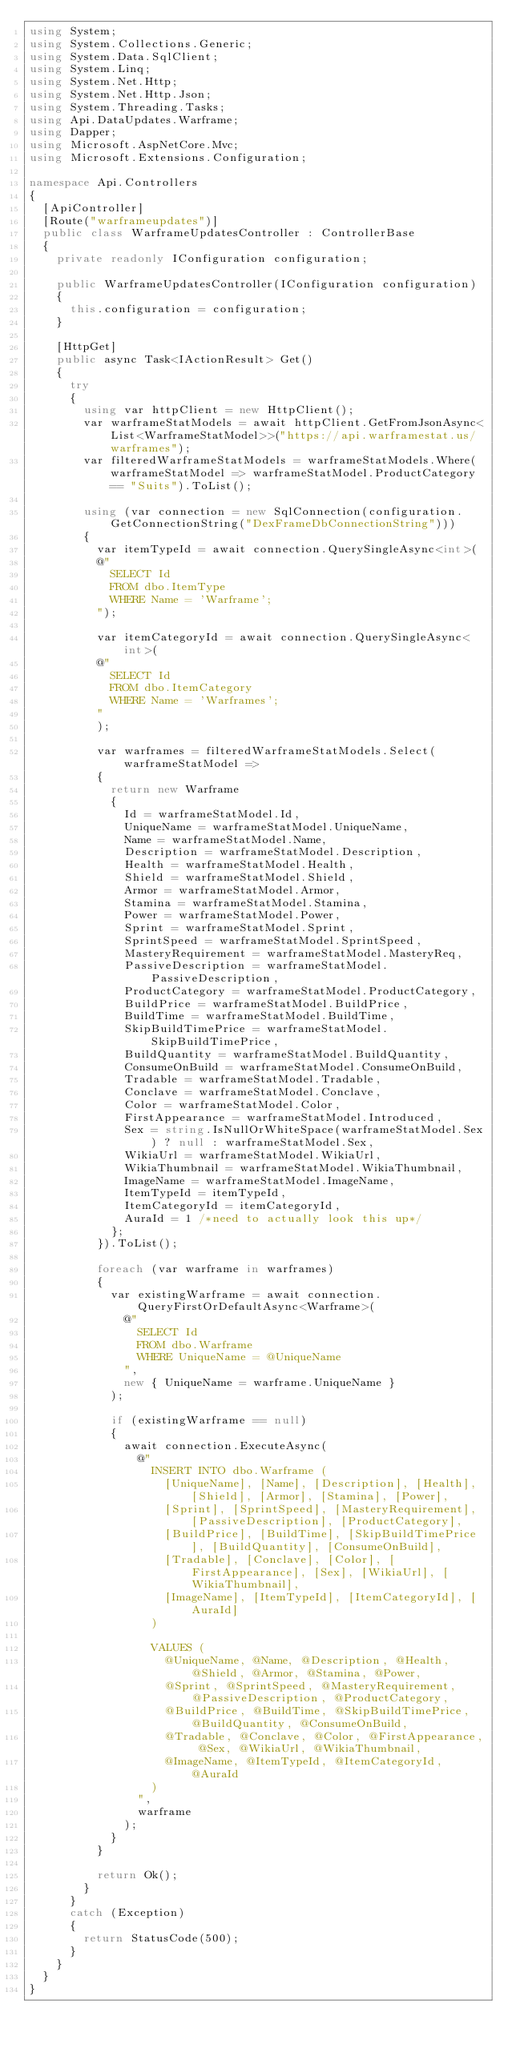<code> <loc_0><loc_0><loc_500><loc_500><_C#_>using System;
using System.Collections.Generic;
using System.Data.SqlClient;
using System.Linq;
using System.Net.Http;
using System.Net.Http.Json;
using System.Threading.Tasks;
using Api.DataUpdates.Warframe;
using Dapper;
using Microsoft.AspNetCore.Mvc;
using Microsoft.Extensions.Configuration;

namespace Api.Controllers
{
  [ApiController]
  [Route("warframeupdates")]
  public class WarframeUpdatesController : ControllerBase
  {
    private readonly IConfiguration configuration;

    public WarframeUpdatesController(IConfiguration configuration)
    {
      this.configuration = configuration;
    }

    [HttpGet]
    public async Task<IActionResult> Get()
    {
      try
      {
        using var httpClient = new HttpClient();
        var warframeStatModels = await httpClient.GetFromJsonAsync<List<WarframeStatModel>>("https://api.warframestat.us/warframes");
        var filteredWarframeStatModels = warframeStatModels.Where(warframeStatModel => warframeStatModel.ProductCategory == "Suits").ToList();

        using (var connection = new SqlConnection(configuration.GetConnectionString("DexFrameDbConnectionString")))
        {
          var itemTypeId = await connection.QuerySingleAsync<int>(
          @"
            SELECT Id
            FROM dbo.ItemType
            WHERE Name = 'Warframe';
          ");

          var itemCategoryId = await connection.QuerySingleAsync<int>(
          @"
            SELECT Id
            FROM dbo.ItemCategory
            WHERE Name = 'Warframes';
          "
          );

          var warframes = filteredWarframeStatModels.Select(warframeStatModel =>
          {
            return new Warframe
            {
              Id = warframeStatModel.Id,
              UniqueName = warframeStatModel.UniqueName,
              Name = warframeStatModel.Name,
              Description = warframeStatModel.Description,
              Health = warframeStatModel.Health,
              Shield = warframeStatModel.Shield,
              Armor = warframeStatModel.Armor,
              Stamina = warframeStatModel.Stamina,
              Power = warframeStatModel.Power,
              Sprint = warframeStatModel.Sprint,
              SprintSpeed = warframeStatModel.SprintSpeed,
              MasteryRequirement = warframeStatModel.MasteryReq,
              PassiveDescription = warframeStatModel.PassiveDescription,
              ProductCategory = warframeStatModel.ProductCategory,
              BuildPrice = warframeStatModel.BuildPrice,
              BuildTime = warframeStatModel.BuildTime,
              SkipBuildTimePrice = warframeStatModel.SkipBuildTimePrice,
              BuildQuantity = warframeStatModel.BuildQuantity,
              ConsumeOnBuild = warframeStatModel.ConsumeOnBuild,
              Tradable = warframeStatModel.Tradable,
              Conclave = warframeStatModel.Conclave,
              Color = warframeStatModel.Color,
              FirstAppearance = warframeStatModel.Introduced,
              Sex = string.IsNullOrWhiteSpace(warframeStatModel.Sex) ? null : warframeStatModel.Sex,
              WikiaUrl = warframeStatModel.WikiaUrl,
              WikiaThumbnail = warframeStatModel.WikiaThumbnail,
              ImageName = warframeStatModel.ImageName,
              ItemTypeId = itemTypeId,
              ItemCategoryId = itemCategoryId,
              AuraId = 1 /*need to actually look this up*/
            };
          }).ToList();

          foreach (var warframe in warframes)
          {
            var existingWarframe = await connection.QueryFirstOrDefaultAsync<Warframe>(
              @"
                SELECT Id
                FROM dbo.Warframe
                WHERE UniqueName = @UniqueName
              ",
              new { UniqueName = warframe.UniqueName }
            );

            if (existingWarframe == null)
            {
              await connection.ExecuteAsync(
                @"
                  INSERT INTO dbo.Warframe (
                    [UniqueName], [Name], [Description], [Health], [Shield], [Armor], [Stamina], [Power],
                    [Sprint], [SprintSpeed], [MasteryRequirement], [PassiveDescription], [ProductCategory],
                    [BuildPrice], [BuildTime], [SkipBuildTimePrice], [BuildQuantity], [ConsumeOnBuild],
                    [Tradable], [Conclave], [Color], [FirstAppearance], [Sex], [WikiaUrl], [WikiaThumbnail],
                    [ImageName], [ItemTypeId], [ItemCategoryId], [AuraId]
                  )
                  
                  VALUES (
                    @UniqueName, @Name, @Description, @Health, @Shield, @Armor, @Stamina, @Power,
                    @Sprint, @SprintSpeed, @MasteryRequirement, @PassiveDescription, @ProductCategory,
                    @BuildPrice, @BuildTime, @SkipBuildTimePrice, @BuildQuantity, @ConsumeOnBuild,
                    @Tradable, @Conclave, @Color, @FirstAppearance, @Sex, @WikiaUrl, @WikiaThumbnail,
                    @ImageName, @ItemTypeId, @ItemCategoryId, @AuraId
                  )
                ",
                warframe
              );
            }
          }

          return Ok();
        }
      }
      catch (Exception)
      {
        return StatusCode(500);
      }
    }
  }
}
</code> 